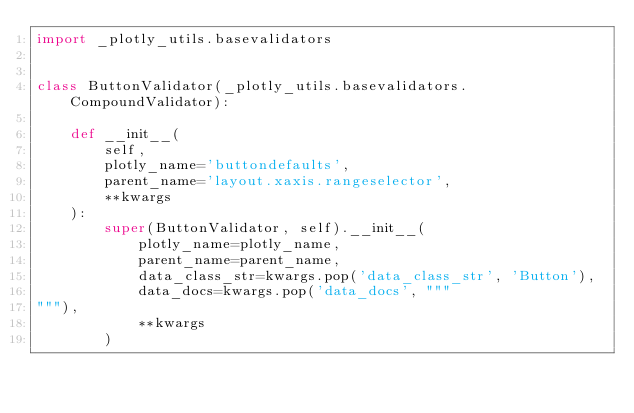<code> <loc_0><loc_0><loc_500><loc_500><_Python_>import _plotly_utils.basevalidators


class ButtonValidator(_plotly_utils.basevalidators.CompoundValidator):

    def __init__(
        self,
        plotly_name='buttondefaults',
        parent_name='layout.xaxis.rangeselector',
        **kwargs
    ):
        super(ButtonValidator, self).__init__(
            plotly_name=plotly_name,
            parent_name=parent_name,
            data_class_str=kwargs.pop('data_class_str', 'Button'),
            data_docs=kwargs.pop('data_docs', """
"""),
            **kwargs
        )
</code> 